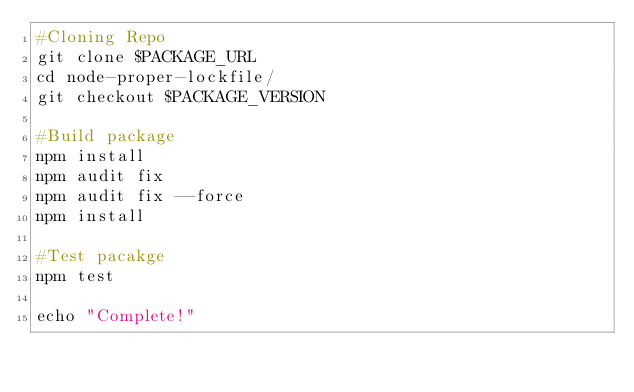<code> <loc_0><loc_0><loc_500><loc_500><_Bash_>#Cloning Repo
git clone $PACKAGE_URL
cd node-proper-lockfile/
git checkout $PACKAGE_VERSION

#Build package
npm install
npm audit fix
npm audit fix --force
npm install

#Test pacakge
npm test 

echo "Complete!"
</code> 